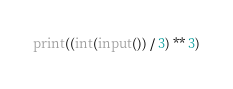Convert code to text. <code><loc_0><loc_0><loc_500><loc_500><_Python_>print((int(input()) / 3) ** 3)</code> 